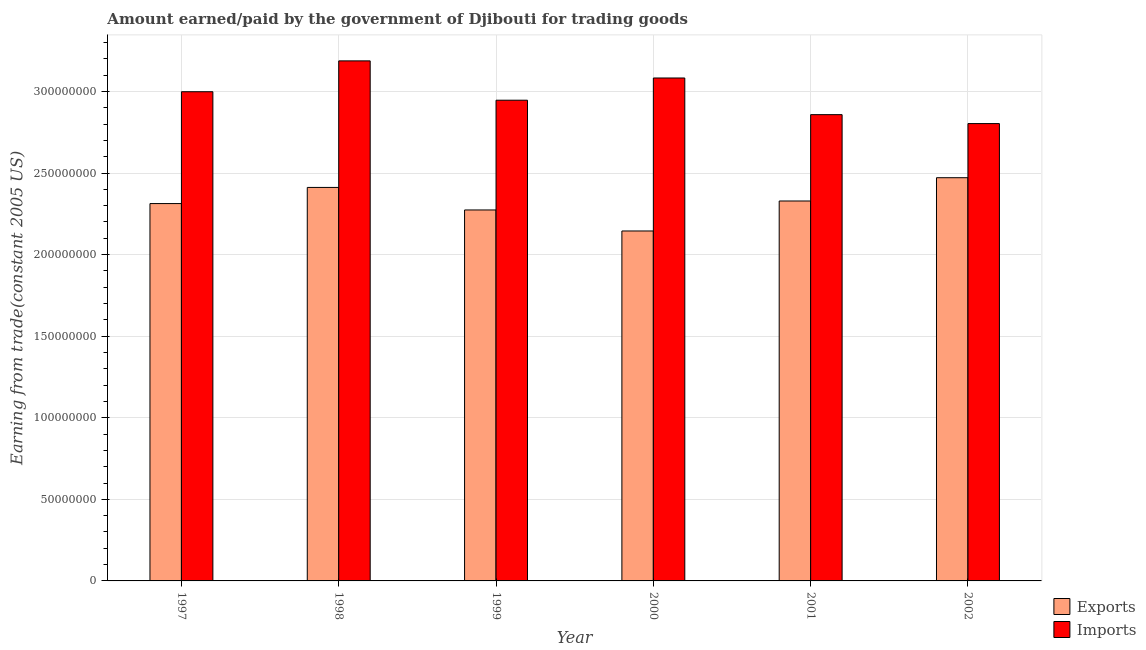How many groups of bars are there?
Your answer should be very brief. 6. What is the label of the 3rd group of bars from the left?
Provide a succinct answer. 1999. In how many cases, is the number of bars for a given year not equal to the number of legend labels?
Provide a succinct answer. 0. What is the amount paid for imports in 2000?
Provide a succinct answer. 3.08e+08. Across all years, what is the maximum amount earned from exports?
Offer a terse response. 2.47e+08. Across all years, what is the minimum amount paid for imports?
Your answer should be very brief. 2.80e+08. In which year was the amount paid for imports minimum?
Keep it short and to the point. 2002. What is the total amount earned from exports in the graph?
Ensure brevity in your answer.  1.39e+09. What is the difference between the amount paid for imports in 1998 and that in 2001?
Make the answer very short. 3.30e+07. What is the difference between the amount paid for imports in 2000 and the amount earned from exports in 1999?
Keep it short and to the point. 1.36e+07. What is the average amount paid for imports per year?
Ensure brevity in your answer.  2.98e+08. In the year 2000, what is the difference between the amount earned from exports and amount paid for imports?
Provide a succinct answer. 0. What is the ratio of the amount paid for imports in 1997 to that in 1998?
Keep it short and to the point. 0.94. What is the difference between the highest and the second highest amount paid for imports?
Offer a very short reply. 1.05e+07. What is the difference between the highest and the lowest amount earned from exports?
Provide a short and direct response. 3.26e+07. Is the sum of the amount earned from exports in 1997 and 1998 greater than the maximum amount paid for imports across all years?
Your answer should be compact. Yes. What does the 2nd bar from the left in 1998 represents?
Keep it short and to the point. Imports. What does the 1st bar from the right in 1999 represents?
Ensure brevity in your answer.  Imports. What is the difference between two consecutive major ticks on the Y-axis?
Provide a succinct answer. 5.00e+07. Are the values on the major ticks of Y-axis written in scientific E-notation?
Give a very brief answer. No. Does the graph contain any zero values?
Make the answer very short. No. Does the graph contain grids?
Ensure brevity in your answer.  Yes. Where does the legend appear in the graph?
Keep it short and to the point. Bottom right. What is the title of the graph?
Provide a short and direct response. Amount earned/paid by the government of Djibouti for trading goods. Does "Crop" appear as one of the legend labels in the graph?
Provide a short and direct response. No. What is the label or title of the Y-axis?
Give a very brief answer. Earning from trade(constant 2005 US). What is the Earning from trade(constant 2005 US) in Exports in 1997?
Offer a terse response. 2.31e+08. What is the Earning from trade(constant 2005 US) in Imports in 1997?
Ensure brevity in your answer.  3.00e+08. What is the Earning from trade(constant 2005 US) of Exports in 1998?
Give a very brief answer. 2.41e+08. What is the Earning from trade(constant 2005 US) of Imports in 1998?
Your response must be concise. 3.19e+08. What is the Earning from trade(constant 2005 US) in Exports in 1999?
Your answer should be compact. 2.27e+08. What is the Earning from trade(constant 2005 US) of Imports in 1999?
Give a very brief answer. 2.95e+08. What is the Earning from trade(constant 2005 US) in Exports in 2000?
Your answer should be compact. 2.14e+08. What is the Earning from trade(constant 2005 US) in Imports in 2000?
Your response must be concise. 3.08e+08. What is the Earning from trade(constant 2005 US) in Exports in 2001?
Give a very brief answer. 2.33e+08. What is the Earning from trade(constant 2005 US) of Imports in 2001?
Your response must be concise. 2.86e+08. What is the Earning from trade(constant 2005 US) in Exports in 2002?
Your response must be concise. 2.47e+08. What is the Earning from trade(constant 2005 US) of Imports in 2002?
Offer a very short reply. 2.80e+08. Across all years, what is the maximum Earning from trade(constant 2005 US) in Exports?
Your response must be concise. 2.47e+08. Across all years, what is the maximum Earning from trade(constant 2005 US) of Imports?
Offer a terse response. 3.19e+08. Across all years, what is the minimum Earning from trade(constant 2005 US) of Exports?
Make the answer very short. 2.14e+08. Across all years, what is the minimum Earning from trade(constant 2005 US) in Imports?
Provide a succinct answer. 2.80e+08. What is the total Earning from trade(constant 2005 US) in Exports in the graph?
Give a very brief answer. 1.39e+09. What is the total Earning from trade(constant 2005 US) in Imports in the graph?
Keep it short and to the point. 1.79e+09. What is the difference between the Earning from trade(constant 2005 US) of Exports in 1997 and that in 1998?
Your answer should be compact. -9.89e+06. What is the difference between the Earning from trade(constant 2005 US) in Imports in 1997 and that in 1998?
Give a very brief answer. -1.89e+07. What is the difference between the Earning from trade(constant 2005 US) in Exports in 1997 and that in 1999?
Your response must be concise. 3.92e+06. What is the difference between the Earning from trade(constant 2005 US) of Imports in 1997 and that in 1999?
Your response must be concise. 5.20e+06. What is the difference between the Earning from trade(constant 2005 US) of Exports in 1997 and that in 2000?
Your answer should be compact. 1.68e+07. What is the difference between the Earning from trade(constant 2005 US) in Imports in 1997 and that in 2000?
Your answer should be compact. -8.42e+06. What is the difference between the Earning from trade(constant 2005 US) in Exports in 1997 and that in 2001?
Provide a succinct answer. -1.57e+06. What is the difference between the Earning from trade(constant 2005 US) of Imports in 1997 and that in 2001?
Your answer should be very brief. 1.40e+07. What is the difference between the Earning from trade(constant 2005 US) in Exports in 1997 and that in 2002?
Offer a very short reply. -1.58e+07. What is the difference between the Earning from trade(constant 2005 US) in Imports in 1997 and that in 2002?
Your answer should be very brief. 1.95e+07. What is the difference between the Earning from trade(constant 2005 US) in Exports in 1998 and that in 1999?
Make the answer very short. 1.38e+07. What is the difference between the Earning from trade(constant 2005 US) in Imports in 1998 and that in 1999?
Offer a terse response. 2.41e+07. What is the difference between the Earning from trade(constant 2005 US) in Exports in 1998 and that in 2000?
Provide a succinct answer. 2.67e+07. What is the difference between the Earning from trade(constant 2005 US) of Imports in 1998 and that in 2000?
Make the answer very short. 1.05e+07. What is the difference between the Earning from trade(constant 2005 US) of Exports in 1998 and that in 2001?
Your answer should be compact. 8.32e+06. What is the difference between the Earning from trade(constant 2005 US) in Imports in 1998 and that in 2001?
Make the answer very short. 3.30e+07. What is the difference between the Earning from trade(constant 2005 US) of Exports in 1998 and that in 2002?
Your answer should be very brief. -5.95e+06. What is the difference between the Earning from trade(constant 2005 US) in Imports in 1998 and that in 2002?
Give a very brief answer. 3.84e+07. What is the difference between the Earning from trade(constant 2005 US) in Exports in 1999 and that in 2000?
Your answer should be very brief. 1.29e+07. What is the difference between the Earning from trade(constant 2005 US) in Imports in 1999 and that in 2000?
Make the answer very short. -1.36e+07. What is the difference between the Earning from trade(constant 2005 US) in Exports in 1999 and that in 2001?
Your answer should be compact. -5.49e+06. What is the difference between the Earning from trade(constant 2005 US) in Imports in 1999 and that in 2001?
Provide a short and direct response. 8.85e+06. What is the difference between the Earning from trade(constant 2005 US) in Exports in 1999 and that in 2002?
Give a very brief answer. -1.98e+07. What is the difference between the Earning from trade(constant 2005 US) of Imports in 1999 and that in 2002?
Make the answer very short. 1.43e+07. What is the difference between the Earning from trade(constant 2005 US) in Exports in 2000 and that in 2001?
Give a very brief answer. -1.84e+07. What is the difference between the Earning from trade(constant 2005 US) of Imports in 2000 and that in 2001?
Keep it short and to the point. 2.25e+07. What is the difference between the Earning from trade(constant 2005 US) of Exports in 2000 and that in 2002?
Ensure brevity in your answer.  -3.26e+07. What is the difference between the Earning from trade(constant 2005 US) in Imports in 2000 and that in 2002?
Your answer should be very brief. 2.79e+07. What is the difference between the Earning from trade(constant 2005 US) of Exports in 2001 and that in 2002?
Your answer should be compact. -1.43e+07. What is the difference between the Earning from trade(constant 2005 US) of Imports in 2001 and that in 2002?
Your answer should be compact. 5.47e+06. What is the difference between the Earning from trade(constant 2005 US) in Exports in 1997 and the Earning from trade(constant 2005 US) in Imports in 1998?
Offer a very short reply. -8.75e+07. What is the difference between the Earning from trade(constant 2005 US) in Exports in 1997 and the Earning from trade(constant 2005 US) in Imports in 1999?
Ensure brevity in your answer.  -6.33e+07. What is the difference between the Earning from trade(constant 2005 US) of Exports in 1997 and the Earning from trade(constant 2005 US) of Imports in 2000?
Offer a terse response. -7.70e+07. What is the difference between the Earning from trade(constant 2005 US) of Exports in 1997 and the Earning from trade(constant 2005 US) of Imports in 2001?
Provide a short and direct response. -5.45e+07. What is the difference between the Earning from trade(constant 2005 US) of Exports in 1997 and the Earning from trade(constant 2005 US) of Imports in 2002?
Provide a succinct answer. -4.90e+07. What is the difference between the Earning from trade(constant 2005 US) in Exports in 1998 and the Earning from trade(constant 2005 US) in Imports in 1999?
Offer a terse response. -5.35e+07. What is the difference between the Earning from trade(constant 2005 US) in Exports in 1998 and the Earning from trade(constant 2005 US) in Imports in 2000?
Your response must be concise. -6.71e+07. What is the difference between the Earning from trade(constant 2005 US) of Exports in 1998 and the Earning from trade(constant 2005 US) of Imports in 2001?
Offer a very short reply. -4.46e+07. What is the difference between the Earning from trade(constant 2005 US) of Exports in 1998 and the Earning from trade(constant 2005 US) of Imports in 2002?
Offer a terse response. -3.91e+07. What is the difference between the Earning from trade(constant 2005 US) in Exports in 1999 and the Earning from trade(constant 2005 US) in Imports in 2000?
Your answer should be compact. -8.09e+07. What is the difference between the Earning from trade(constant 2005 US) of Exports in 1999 and the Earning from trade(constant 2005 US) of Imports in 2001?
Ensure brevity in your answer.  -5.84e+07. What is the difference between the Earning from trade(constant 2005 US) of Exports in 1999 and the Earning from trade(constant 2005 US) of Imports in 2002?
Keep it short and to the point. -5.29e+07. What is the difference between the Earning from trade(constant 2005 US) in Exports in 2000 and the Earning from trade(constant 2005 US) in Imports in 2001?
Your response must be concise. -7.13e+07. What is the difference between the Earning from trade(constant 2005 US) in Exports in 2000 and the Earning from trade(constant 2005 US) in Imports in 2002?
Your answer should be compact. -6.58e+07. What is the difference between the Earning from trade(constant 2005 US) in Exports in 2001 and the Earning from trade(constant 2005 US) in Imports in 2002?
Provide a succinct answer. -4.75e+07. What is the average Earning from trade(constant 2005 US) of Exports per year?
Keep it short and to the point. 2.32e+08. What is the average Earning from trade(constant 2005 US) in Imports per year?
Your answer should be compact. 2.98e+08. In the year 1997, what is the difference between the Earning from trade(constant 2005 US) in Exports and Earning from trade(constant 2005 US) in Imports?
Your answer should be very brief. -6.85e+07. In the year 1998, what is the difference between the Earning from trade(constant 2005 US) in Exports and Earning from trade(constant 2005 US) in Imports?
Give a very brief answer. -7.76e+07. In the year 1999, what is the difference between the Earning from trade(constant 2005 US) of Exports and Earning from trade(constant 2005 US) of Imports?
Ensure brevity in your answer.  -6.73e+07. In the year 2000, what is the difference between the Earning from trade(constant 2005 US) in Exports and Earning from trade(constant 2005 US) in Imports?
Provide a short and direct response. -9.38e+07. In the year 2001, what is the difference between the Earning from trade(constant 2005 US) of Exports and Earning from trade(constant 2005 US) of Imports?
Provide a short and direct response. -5.29e+07. In the year 2002, what is the difference between the Earning from trade(constant 2005 US) of Exports and Earning from trade(constant 2005 US) of Imports?
Your answer should be compact. -3.32e+07. What is the ratio of the Earning from trade(constant 2005 US) of Exports in 1997 to that in 1998?
Give a very brief answer. 0.96. What is the ratio of the Earning from trade(constant 2005 US) of Imports in 1997 to that in 1998?
Give a very brief answer. 0.94. What is the ratio of the Earning from trade(constant 2005 US) of Exports in 1997 to that in 1999?
Offer a terse response. 1.02. What is the ratio of the Earning from trade(constant 2005 US) of Imports in 1997 to that in 1999?
Your answer should be very brief. 1.02. What is the ratio of the Earning from trade(constant 2005 US) in Exports in 1997 to that in 2000?
Offer a very short reply. 1.08. What is the ratio of the Earning from trade(constant 2005 US) in Imports in 1997 to that in 2000?
Provide a succinct answer. 0.97. What is the ratio of the Earning from trade(constant 2005 US) of Imports in 1997 to that in 2001?
Provide a short and direct response. 1.05. What is the ratio of the Earning from trade(constant 2005 US) in Exports in 1997 to that in 2002?
Offer a terse response. 0.94. What is the ratio of the Earning from trade(constant 2005 US) in Imports in 1997 to that in 2002?
Ensure brevity in your answer.  1.07. What is the ratio of the Earning from trade(constant 2005 US) of Exports in 1998 to that in 1999?
Your answer should be very brief. 1.06. What is the ratio of the Earning from trade(constant 2005 US) in Imports in 1998 to that in 1999?
Provide a succinct answer. 1.08. What is the ratio of the Earning from trade(constant 2005 US) in Exports in 1998 to that in 2000?
Your answer should be compact. 1.12. What is the ratio of the Earning from trade(constant 2005 US) in Imports in 1998 to that in 2000?
Provide a short and direct response. 1.03. What is the ratio of the Earning from trade(constant 2005 US) of Exports in 1998 to that in 2001?
Ensure brevity in your answer.  1.04. What is the ratio of the Earning from trade(constant 2005 US) of Imports in 1998 to that in 2001?
Provide a succinct answer. 1.12. What is the ratio of the Earning from trade(constant 2005 US) in Exports in 1998 to that in 2002?
Offer a very short reply. 0.98. What is the ratio of the Earning from trade(constant 2005 US) of Imports in 1998 to that in 2002?
Make the answer very short. 1.14. What is the ratio of the Earning from trade(constant 2005 US) in Exports in 1999 to that in 2000?
Keep it short and to the point. 1.06. What is the ratio of the Earning from trade(constant 2005 US) in Imports in 1999 to that in 2000?
Your answer should be very brief. 0.96. What is the ratio of the Earning from trade(constant 2005 US) of Exports in 1999 to that in 2001?
Make the answer very short. 0.98. What is the ratio of the Earning from trade(constant 2005 US) in Imports in 1999 to that in 2001?
Ensure brevity in your answer.  1.03. What is the ratio of the Earning from trade(constant 2005 US) of Exports in 1999 to that in 2002?
Offer a terse response. 0.92. What is the ratio of the Earning from trade(constant 2005 US) in Imports in 1999 to that in 2002?
Make the answer very short. 1.05. What is the ratio of the Earning from trade(constant 2005 US) in Exports in 2000 to that in 2001?
Offer a terse response. 0.92. What is the ratio of the Earning from trade(constant 2005 US) in Imports in 2000 to that in 2001?
Your response must be concise. 1.08. What is the ratio of the Earning from trade(constant 2005 US) in Exports in 2000 to that in 2002?
Your answer should be very brief. 0.87. What is the ratio of the Earning from trade(constant 2005 US) of Imports in 2000 to that in 2002?
Offer a very short reply. 1.1. What is the ratio of the Earning from trade(constant 2005 US) in Exports in 2001 to that in 2002?
Provide a short and direct response. 0.94. What is the ratio of the Earning from trade(constant 2005 US) in Imports in 2001 to that in 2002?
Ensure brevity in your answer.  1.02. What is the difference between the highest and the second highest Earning from trade(constant 2005 US) in Exports?
Keep it short and to the point. 5.95e+06. What is the difference between the highest and the second highest Earning from trade(constant 2005 US) in Imports?
Give a very brief answer. 1.05e+07. What is the difference between the highest and the lowest Earning from trade(constant 2005 US) of Exports?
Offer a very short reply. 3.26e+07. What is the difference between the highest and the lowest Earning from trade(constant 2005 US) of Imports?
Offer a very short reply. 3.84e+07. 